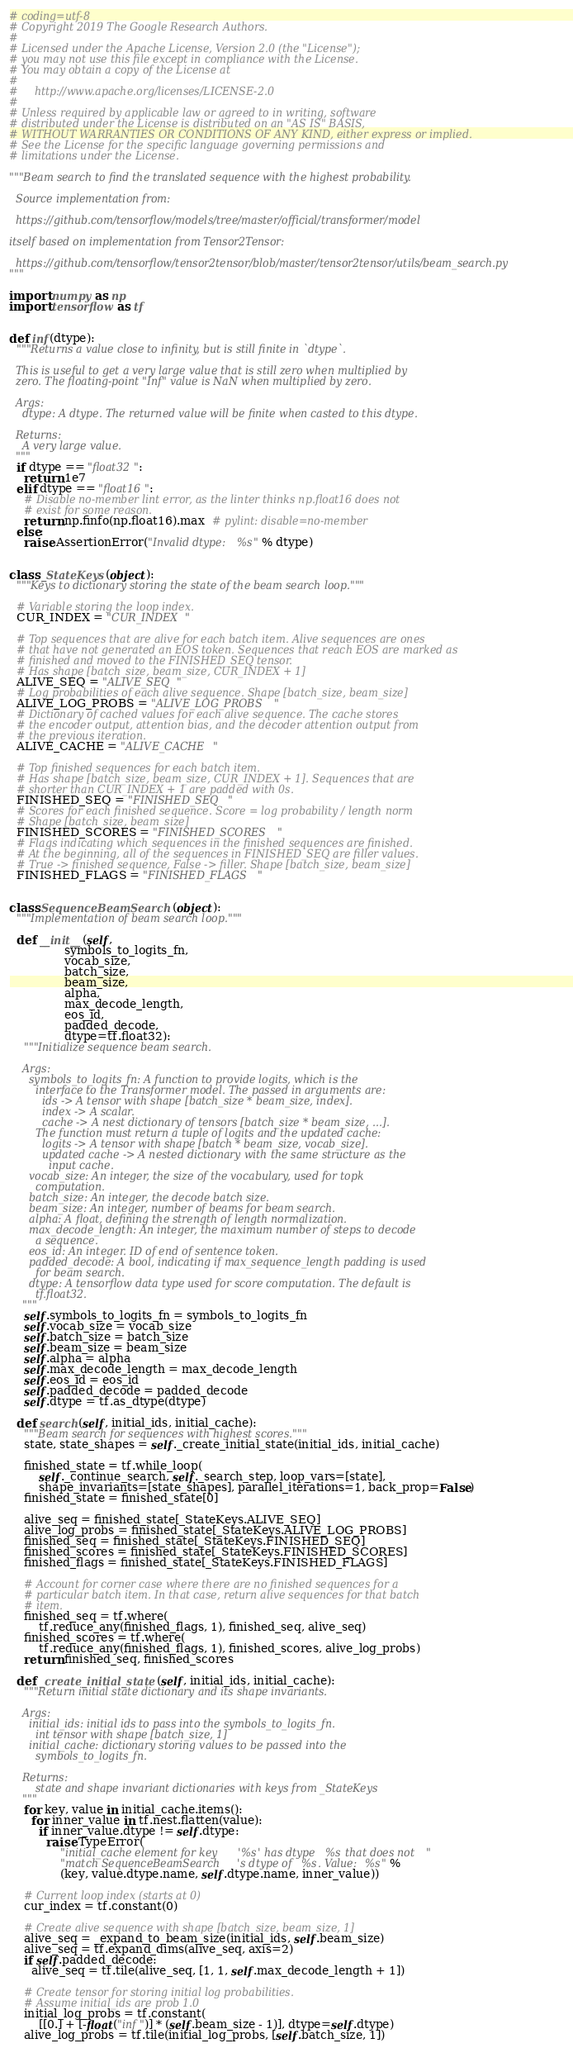<code> <loc_0><loc_0><loc_500><loc_500><_Python_># coding=utf-8
# Copyright 2019 The Google Research Authors.
#
# Licensed under the Apache License, Version 2.0 (the "License");
# you may not use this file except in compliance with the License.
# You may obtain a copy of the License at
#
#     http://www.apache.org/licenses/LICENSE-2.0
#
# Unless required by applicable law or agreed to in writing, software
# distributed under the License is distributed on an "AS IS" BASIS,
# WITHOUT WARRANTIES OR CONDITIONS OF ANY KIND, either express or implied.
# See the License for the specific language governing permissions and
# limitations under the License.

"""Beam search to find the translated sequence with the highest probability.

  Source implementation from:

  https://github.com/tensorflow/models/tree/master/official/transformer/model

itself based on implementation from Tensor2Tensor:

  https://github.com/tensorflow/tensor2tensor/blob/master/tensor2tensor/utils/beam_search.py
"""

import numpy as np
import tensorflow as tf


def inf(dtype):
  """Returns a value close to infinity, but is still finite in `dtype`.

  This is useful to get a very large value that is still zero when multiplied by
  zero. The floating-point "Inf" value is NaN when multiplied by zero.

  Args:
    dtype: A dtype. The returned value will be finite when casted to this dtype.

  Returns:
    A very large value.
  """
  if dtype == "float32":
    return 1e7
  elif dtype == "float16":
    # Disable no-member lint error, as the linter thinks np.float16 does not
    # exist for some reason.
    return np.finfo(np.float16).max  # pylint: disable=no-member
  else:
    raise AssertionError("Invalid dtype: %s" % dtype)


class _StateKeys(object):
  """Keys to dictionary storing the state of the beam search loop."""

  # Variable storing the loop index.
  CUR_INDEX = "CUR_INDEX"

  # Top sequences that are alive for each batch item. Alive sequences are ones
  # that have not generated an EOS token. Sequences that reach EOS are marked as
  # finished and moved to the FINISHED_SEQ tensor.
  # Has shape [batch_size, beam_size, CUR_INDEX + 1]
  ALIVE_SEQ = "ALIVE_SEQ"
  # Log probabilities of each alive sequence. Shape [batch_size, beam_size]
  ALIVE_LOG_PROBS = "ALIVE_LOG_PROBS"
  # Dictionary of cached values for each alive sequence. The cache stores
  # the encoder output, attention bias, and the decoder attention output from
  # the previous iteration.
  ALIVE_CACHE = "ALIVE_CACHE"

  # Top finished sequences for each batch item.
  # Has shape [batch_size, beam_size, CUR_INDEX + 1]. Sequences that are
  # shorter than CUR_INDEX + 1 are padded with 0s.
  FINISHED_SEQ = "FINISHED_SEQ"
  # Scores for each finished sequence. Score = log probability / length norm
  # Shape [batch_size, beam_size]
  FINISHED_SCORES = "FINISHED_SCORES"
  # Flags indicating which sequences in the finished sequences are finished.
  # At the beginning, all of the sequences in FINISHED_SEQ are filler values.
  # True -> finished sequence, False -> filler. Shape [batch_size, beam_size]
  FINISHED_FLAGS = "FINISHED_FLAGS"


class SequenceBeamSearch(object):
  """Implementation of beam search loop."""

  def __init__(self,
               symbols_to_logits_fn,
               vocab_size,
               batch_size,
               beam_size,
               alpha,
               max_decode_length,
               eos_id,
               padded_decode,
               dtype=tf.float32):
    """Initialize sequence beam search.

    Args:
      symbols_to_logits_fn: A function to provide logits, which is the
        interface to the Transformer model. The passed in arguments are:
          ids -> A tensor with shape [batch_size * beam_size, index].
          index -> A scalar.
          cache -> A nest dictionary of tensors [batch_size * beam_size, ...].
        The function must return a tuple of logits and the updated cache:
          logits -> A tensor with shape [batch * beam_size, vocab_size].
          updated cache -> A nested dictionary with the same structure as the
            input cache.
      vocab_size: An integer, the size of the vocabulary, used for topk
        computation.
      batch_size: An integer, the decode batch size.
      beam_size: An integer, number of beams for beam search.
      alpha: A float, defining the strength of length normalization.
      max_decode_length: An integer, the maximum number of steps to decode
        a sequence.
      eos_id: An integer. ID of end of sentence token.
      padded_decode: A bool, indicating if max_sequence_length padding is used
        for beam search.
      dtype: A tensorflow data type used for score computation. The default is
        tf.float32.
    """
    self.symbols_to_logits_fn = symbols_to_logits_fn
    self.vocab_size = vocab_size
    self.batch_size = batch_size
    self.beam_size = beam_size
    self.alpha = alpha
    self.max_decode_length = max_decode_length
    self.eos_id = eos_id
    self.padded_decode = padded_decode
    self.dtype = tf.as_dtype(dtype)

  def search(self, initial_ids, initial_cache):
    """Beam search for sequences with highest scores."""
    state, state_shapes = self._create_initial_state(initial_ids, initial_cache)

    finished_state = tf.while_loop(
        self._continue_search, self._search_step, loop_vars=[state],
        shape_invariants=[state_shapes], parallel_iterations=1, back_prop=False)
    finished_state = finished_state[0]

    alive_seq = finished_state[_StateKeys.ALIVE_SEQ]
    alive_log_probs = finished_state[_StateKeys.ALIVE_LOG_PROBS]
    finished_seq = finished_state[_StateKeys.FINISHED_SEQ]
    finished_scores = finished_state[_StateKeys.FINISHED_SCORES]
    finished_flags = finished_state[_StateKeys.FINISHED_FLAGS]

    # Account for corner case where there are no finished sequences for a
    # particular batch item. In that case, return alive sequences for that batch
    # item.
    finished_seq = tf.where(
        tf.reduce_any(finished_flags, 1), finished_seq, alive_seq)
    finished_scores = tf.where(
        tf.reduce_any(finished_flags, 1), finished_scores, alive_log_probs)
    return finished_seq, finished_scores

  def _create_initial_state(self, initial_ids, initial_cache):
    """Return initial state dictionary and its shape invariants.

    Args:
      initial_ids: initial ids to pass into the symbols_to_logits_fn.
        int tensor with shape [batch_size, 1]
      initial_cache: dictionary storing values to be passed into the
        symbols_to_logits_fn.

    Returns:
        state and shape invariant dictionaries with keys from _StateKeys
    """
    for key, value in initial_cache.items():
      for inner_value in tf.nest.flatten(value):
        if inner_value.dtype != self.dtype:
          raise TypeError(
              "initial_cache element for key '%s' has dtype %s that does not "
              "match SequenceBeamSearch's dtype of %s. Value: %s" %
              (key, value.dtype.name, self.dtype.name, inner_value))

    # Current loop index (starts at 0)
    cur_index = tf.constant(0)

    # Create alive sequence with shape [batch_size, beam_size, 1]
    alive_seq = _expand_to_beam_size(initial_ids, self.beam_size)
    alive_seq = tf.expand_dims(alive_seq, axis=2)
    if self.padded_decode:
      alive_seq = tf.tile(alive_seq, [1, 1, self.max_decode_length + 1])

    # Create tensor for storing initial log probabilities.
    # Assume initial_ids are prob 1.0
    initial_log_probs = tf.constant(
        [[0.] + [-float("inf")] * (self.beam_size - 1)], dtype=self.dtype)
    alive_log_probs = tf.tile(initial_log_probs, [self.batch_size, 1])
</code> 